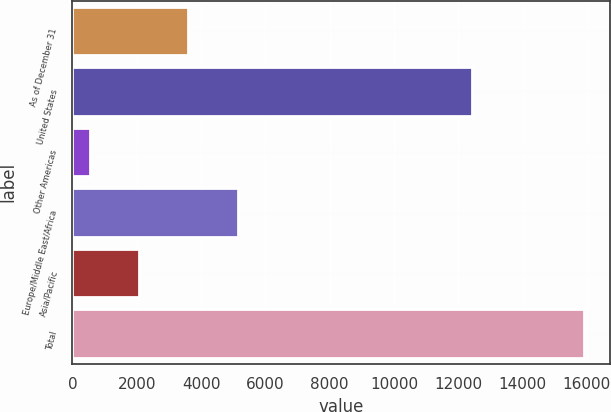<chart> <loc_0><loc_0><loc_500><loc_500><bar_chart><fcel>As of December 31<fcel>United States<fcel>Other Americas<fcel>Europe/Middle East/Africa<fcel>Asia/Pacific<fcel>Total<nl><fcel>3610.2<fcel>12424<fcel>536<fcel>5147.3<fcel>2073.1<fcel>15907<nl></chart> 